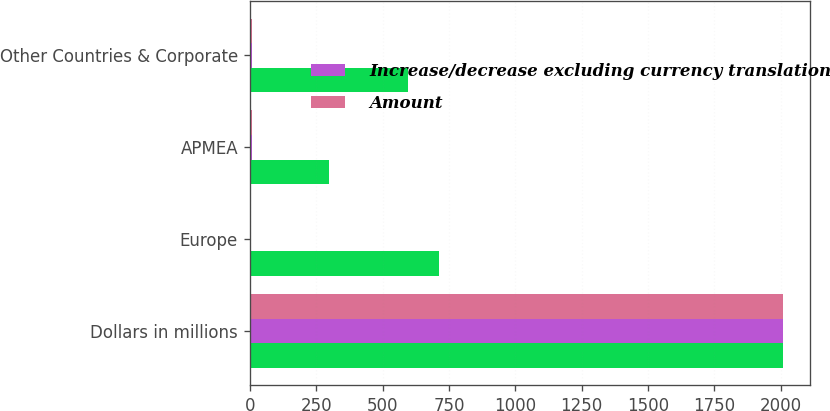Convert chart to OTSL. <chart><loc_0><loc_0><loc_500><loc_500><stacked_bar_chart><ecel><fcel>Dollars in millions<fcel>Europe<fcel>APMEA<fcel>Other Countries & Corporate<nl><fcel>nan<fcel>2008<fcel>714<fcel>300<fcel>596<nl><fcel>Increase/decrease excluding currency translation<fcel>2008<fcel>4<fcel>9<fcel>9<nl><fcel>Amount<fcel>2008<fcel>1<fcel>8<fcel>9<nl></chart> 